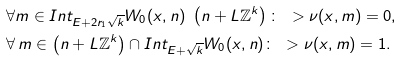<formula> <loc_0><loc_0><loc_500><loc_500>& \forall m \in I n t _ { E + 2 r _ { 1 } \sqrt { k } } W _ { 0 } ( x , n ) \ \left ( n + L \mathbb { Z } ^ { k } \right ) \colon \ > \nu ( x , m ) = 0 , \\ & \forall \, m \in \left ( n + L \mathbb { Z } ^ { k } \right ) \cap I n t _ { E + \sqrt { k } } W _ { 0 } ( x , n ) \colon \ > \nu ( x , m ) = 1 .</formula> 